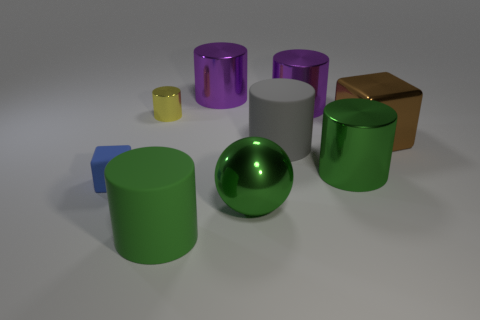Subtract all spheres. How many objects are left? 8 Subtract 1 spheres. How many spheres are left? 0 Subtract all brown blocks. Subtract all blue cylinders. How many blocks are left? 1 Subtract all blue cubes. How many green cylinders are left? 2 Subtract all yellow metal objects. Subtract all green metal spheres. How many objects are left? 7 Add 8 large purple metallic cylinders. How many large purple metallic cylinders are left? 10 Add 4 large purple metallic cylinders. How many large purple metallic cylinders exist? 6 Add 1 small brown metal objects. How many objects exist? 10 Subtract all yellow cylinders. How many cylinders are left? 5 Subtract all purple metallic cylinders. How many cylinders are left? 4 